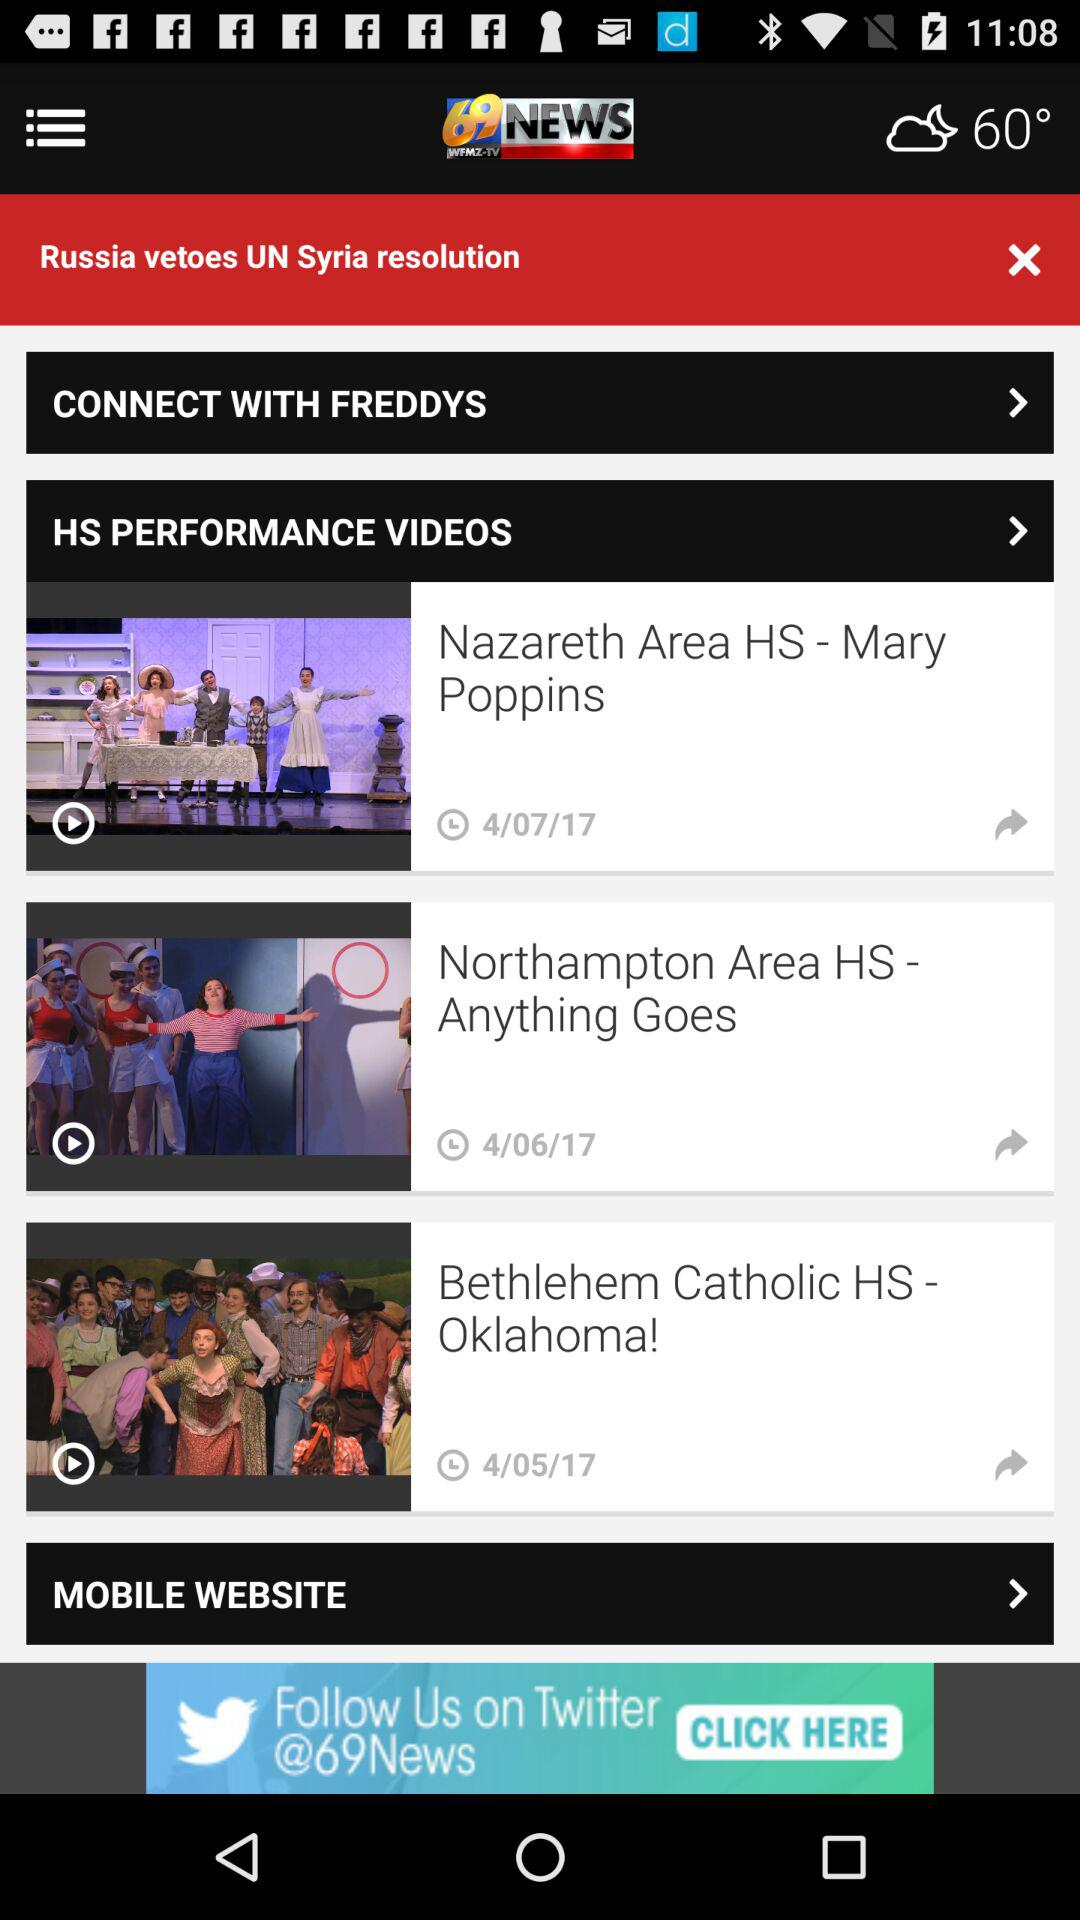What is the temperature? The temperature is 60°. 